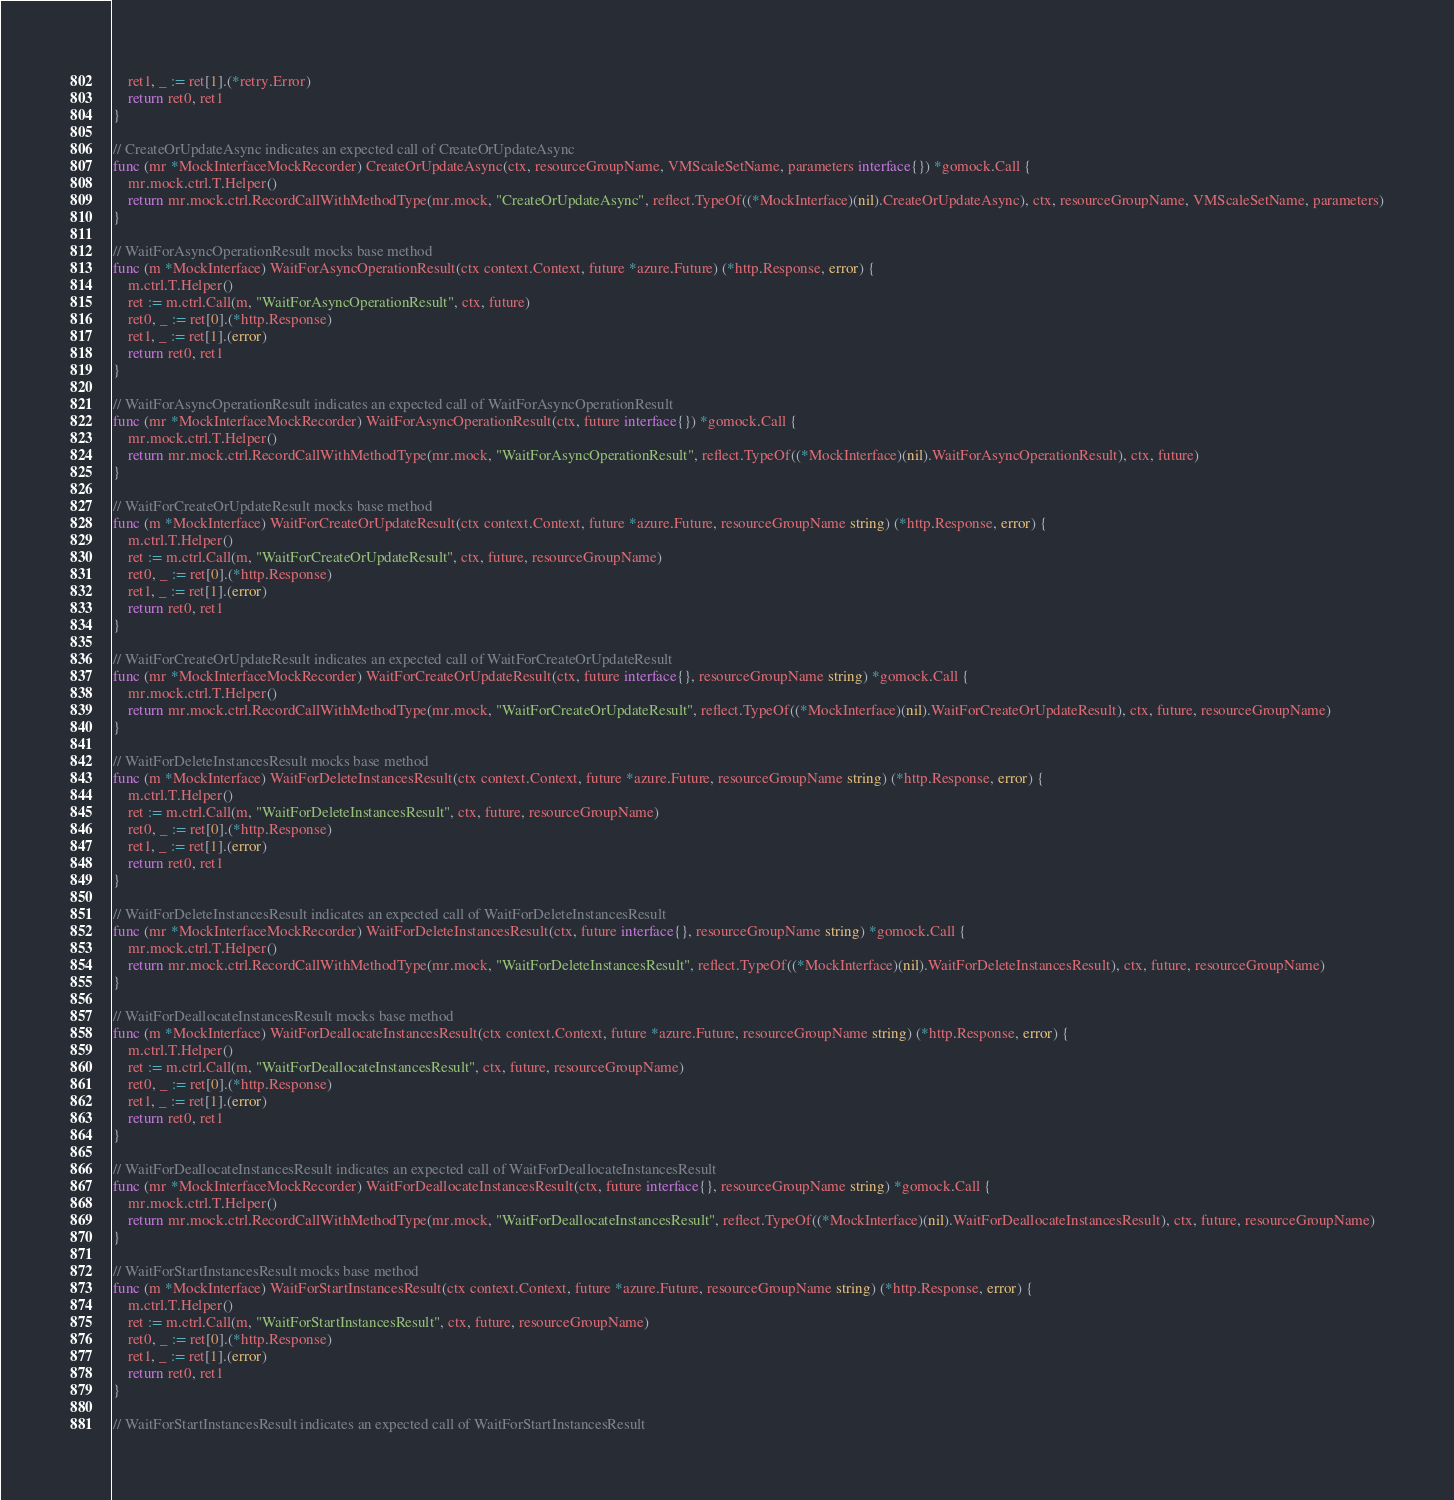Convert code to text. <code><loc_0><loc_0><loc_500><loc_500><_Go_>	ret1, _ := ret[1].(*retry.Error)
	return ret0, ret1
}

// CreateOrUpdateAsync indicates an expected call of CreateOrUpdateAsync
func (mr *MockInterfaceMockRecorder) CreateOrUpdateAsync(ctx, resourceGroupName, VMScaleSetName, parameters interface{}) *gomock.Call {
	mr.mock.ctrl.T.Helper()
	return mr.mock.ctrl.RecordCallWithMethodType(mr.mock, "CreateOrUpdateAsync", reflect.TypeOf((*MockInterface)(nil).CreateOrUpdateAsync), ctx, resourceGroupName, VMScaleSetName, parameters)
}

// WaitForAsyncOperationResult mocks base method
func (m *MockInterface) WaitForAsyncOperationResult(ctx context.Context, future *azure.Future) (*http.Response, error) {
	m.ctrl.T.Helper()
	ret := m.ctrl.Call(m, "WaitForAsyncOperationResult", ctx, future)
	ret0, _ := ret[0].(*http.Response)
	ret1, _ := ret[1].(error)
	return ret0, ret1
}

// WaitForAsyncOperationResult indicates an expected call of WaitForAsyncOperationResult
func (mr *MockInterfaceMockRecorder) WaitForAsyncOperationResult(ctx, future interface{}) *gomock.Call {
	mr.mock.ctrl.T.Helper()
	return mr.mock.ctrl.RecordCallWithMethodType(mr.mock, "WaitForAsyncOperationResult", reflect.TypeOf((*MockInterface)(nil).WaitForAsyncOperationResult), ctx, future)
}

// WaitForCreateOrUpdateResult mocks base method
func (m *MockInterface) WaitForCreateOrUpdateResult(ctx context.Context, future *azure.Future, resourceGroupName string) (*http.Response, error) {
	m.ctrl.T.Helper()
	ret := m.ctrl.Call(m, "WaitForCreateOrUpdateResult", ctx, future, resourceGroupName)
	ret0, _ := ret[0].(*http.Response)
	ret1, _ := ret[1].(error)
	return ret0, ret1
}

// WaitForCreateOrUpdateResult indicates an expected call of WaitForCreateOrUpdateResult
func (mr *MockInterfaceMockRecorder) WaitForCreateOrUpdateResult(ctx, future interface{}, resourceGroupName string) *gomock.Call {
	mr.mock.ctrl.T.Helper()
	return mr.mock.ctrl.RecordCallWithMethodType(mr.mock, "WaitForCreateOrUpdateResult", reflect.TypeOf((*MockInterface)(nil).WaitForCreateOrUpdateResult), ctx, future, resourceGroupName)
}

// WaitForDeleteInstancesResult mocks base method
func (m *MockInterface) WaitForDeleteInstancesResult(ctx context.Context, future *azure.Future, resourceGroupName string) (*http.Response, error) {
	m.ctrl.T.Helper()
	ret := m.ctrl.Call(m, "WaitForDeleteInstancesResult", ctx, future, resourceGroupName)
	ret0, _ := ret[0].(*http.Response)
	ret1, _ := ret[1].(error)
	return ret0, ret1
}

// WaitForDeleteInstancesResult indicates an expected call of WaitForDeleteInstancesResult
func (mr *MockInterfaceMockRecorder) WaitForDeleteInstancesResult(ctx, future interface{}, resourceGroupName string) *gomock.Call {
	mr.mock.ctrl.T.Helper()
	return mr.mock.ctrl.RecordCallWithMethodType(mr.mock, "WaitForDeleteInstancesResult", reflect.TypeOf((*MockInterface)(nil).WaitForDeleteInstancesResult), ctx, future, resourceGroupName)
}

// WaitForDeallocateInstancesResult mocks base method
func (m *MockInterface) WaitForDeallocateInstancesResult(ctx context.Context, future *azure.Future, resourceGroupName string) (*http.Response, error) {
	m.ctrl.T.Helper()
	ret := m.ctrl.Call(m, "WaitForDeallocateInstancesResult", ctx, future, resourceGroupName)
	ret0, _ := ret[0].(*http.Response)
	ret1, _ := ret[1].(error)
	return ret0, ret1
}

// WaitForDeallocateInstancesResult indicates an expected call of WaitForDeallocateInstancesResult
func (mr *MockInterfaceMockRecorder) WaitForDeallocateInstancesResult(ctx, future interface{}, resourceGroupName string) *gomock.Call {
	mr.mock.ctrl.T.Helper()
	return mr.mock.ctrl.RecordCallWithMethodType(mr.mock, "WaitForDeallocateInstancesResult", reflect.TypeOf((*MockInterface)(nil).WaitForDeallocateInstancesResult), ctx, future, resourceGroupName)
}

// WaitForStartInstancesResult mocks base method
func (m *MockInterface) WaitForStartInstancesResult(ctx context.Context, future *azure.Future, resourceGroupName string) (*http.Response, error) {
	m.ctrl.T.Helper()
	ret := m.ctrl.Call(m, "WaitForStartInstancesResult", ctx, future, resourceGroupName)
	ret0, _ := ret[0].(*http.Response)
	ret1, _ := ret[1].(error)
	return ret0, ret1
}

// WaitForStartInstancesResult indicates an expected call of WaitForStartInstancesResult</code> 